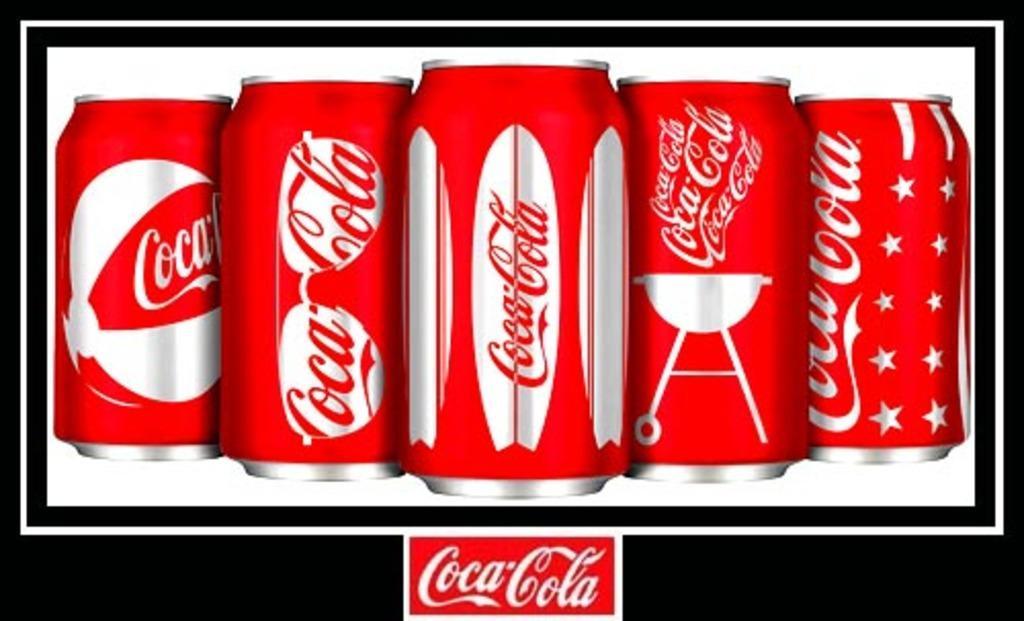In one or two sentences, can you explain what this image depicts? In this image I can see the cool drink bottles with some text written on it. 